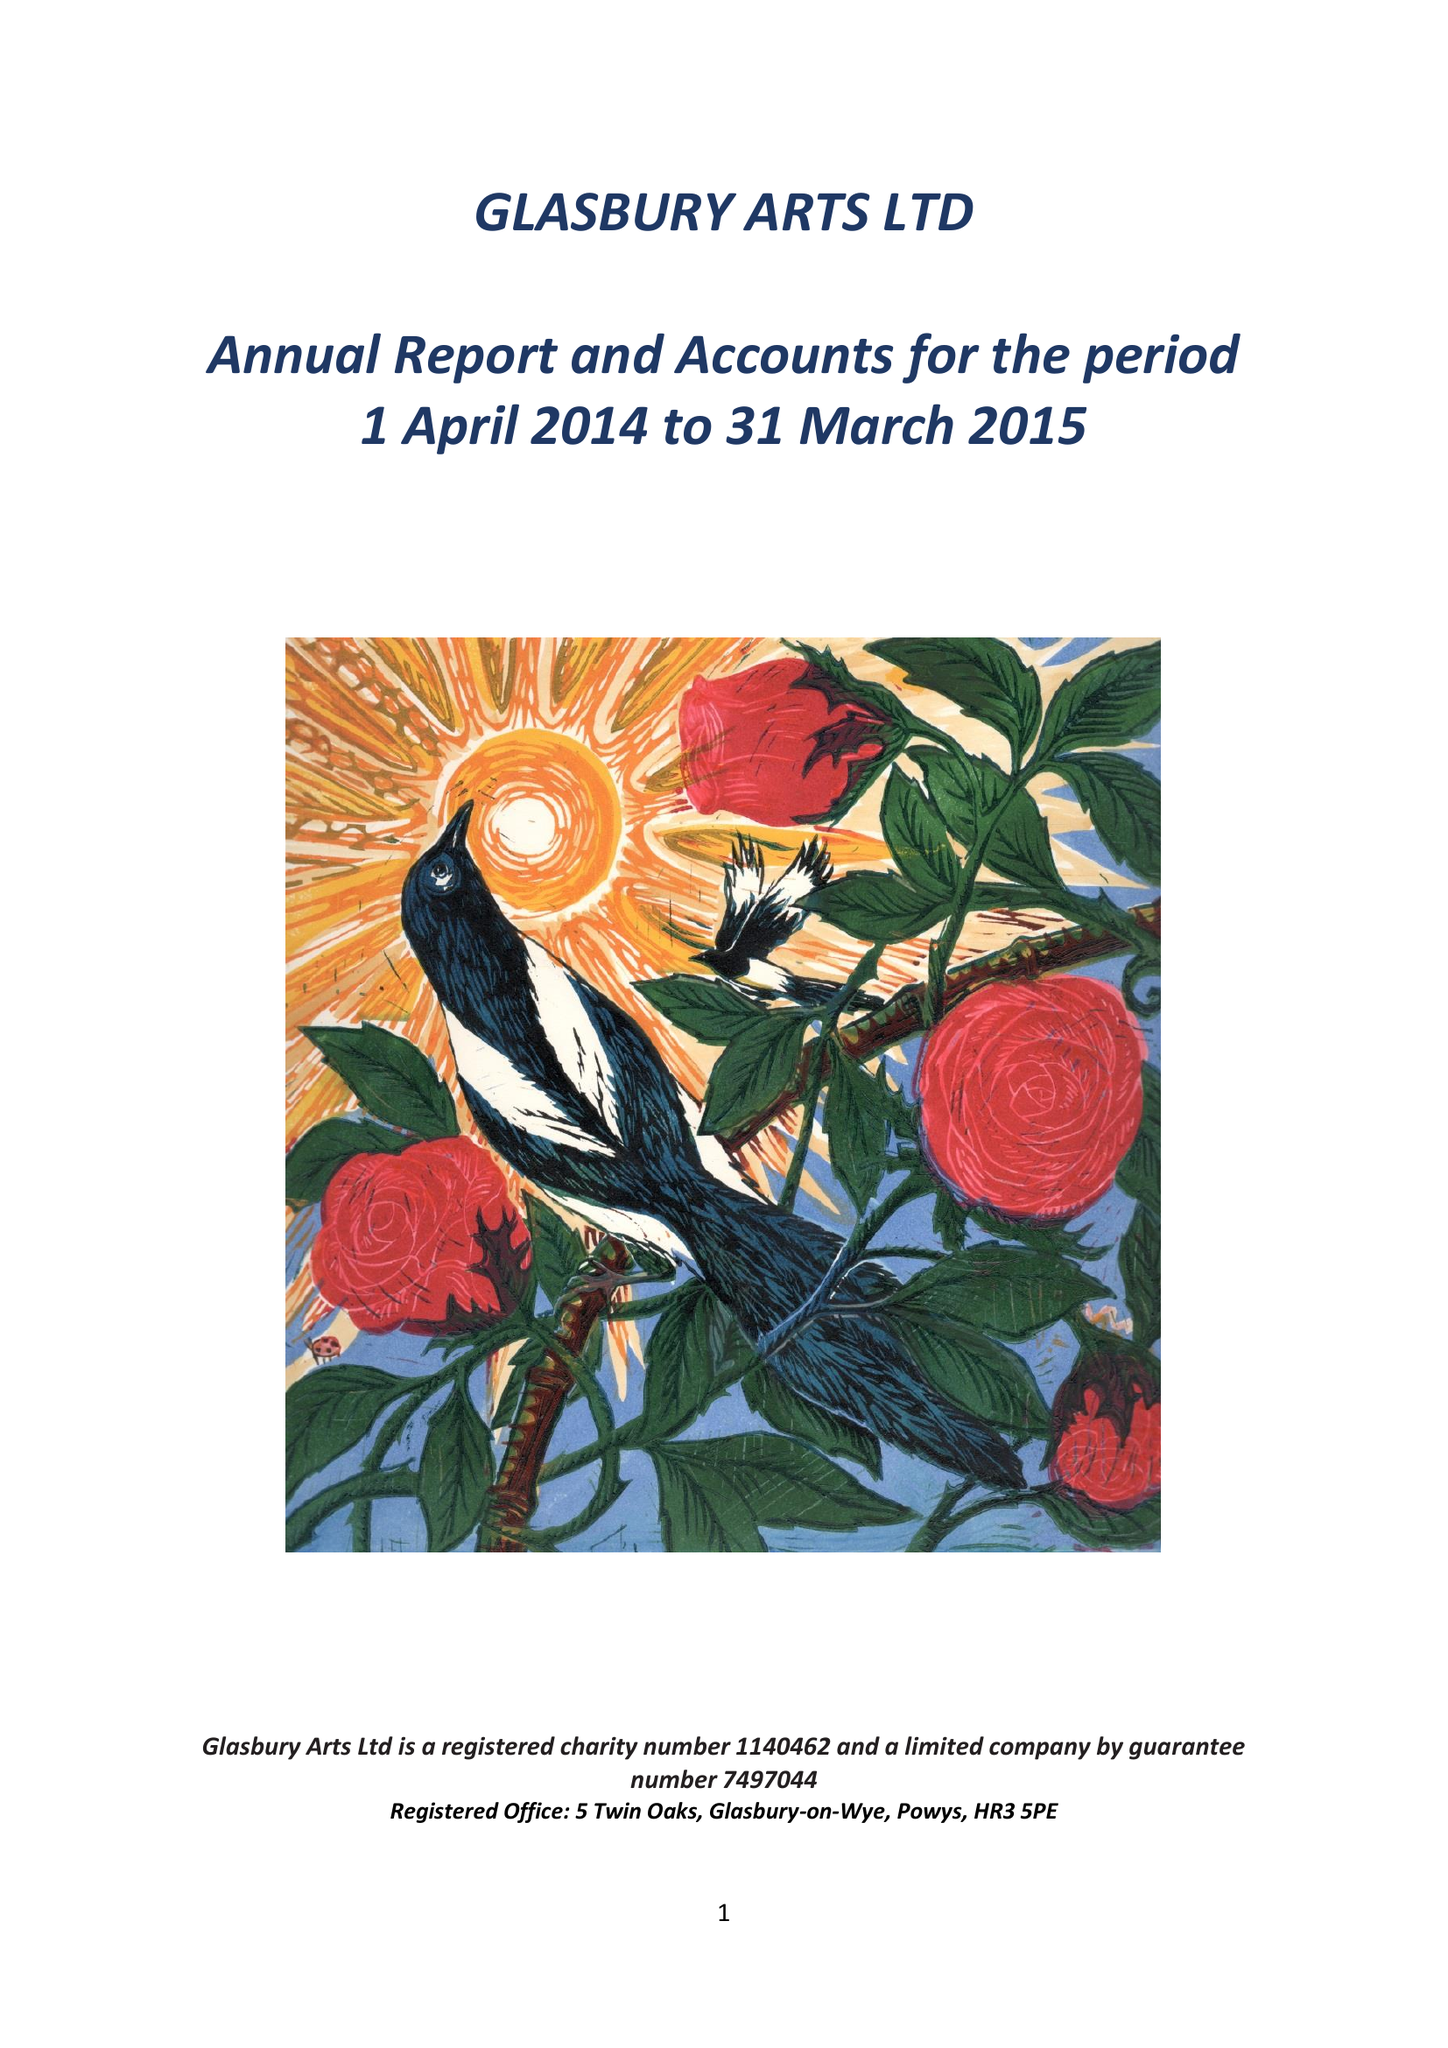What is the value for the charity_number?
Answer the question using a single word or phrase. 1140462 